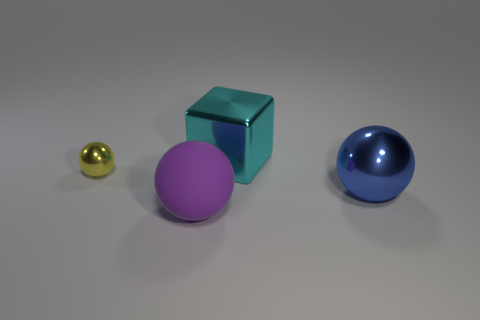Subtract all big purple matte balls. How many balls are left? 2 Add 2 big brown balls. How many objects exist? 6 Subtract all cubes. How many objects are left? 3 Subtract all tiny cyan shiny spheres. Subtract all large things. How many objects are left? 1 Add 4 large blue metal objects. How many large blue metal objects are left? 5 Add 3 tiny yellow metallic objects. How many tiny yellow metallic objects exist? 4 Subtract 0 gray cylinders. How many objects are left? 4 Subtract all cyan balls. Subtract all green blocks. How many balls are left? 3 